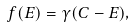<formula> <loc_0><loc_0><loc_500><loc_500>f ( E ) = \gamma ( C - E ) ,</formula> 